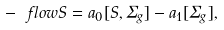Convert formula to latex. <formula><loc_0><loc_0><loc_500><loc_500>- \ f l o w S = a _ { 0 } [ S , \Sigma _ { g } ] - a _ { 1 } [ \Sigma _ { g } ] ,</formula> 